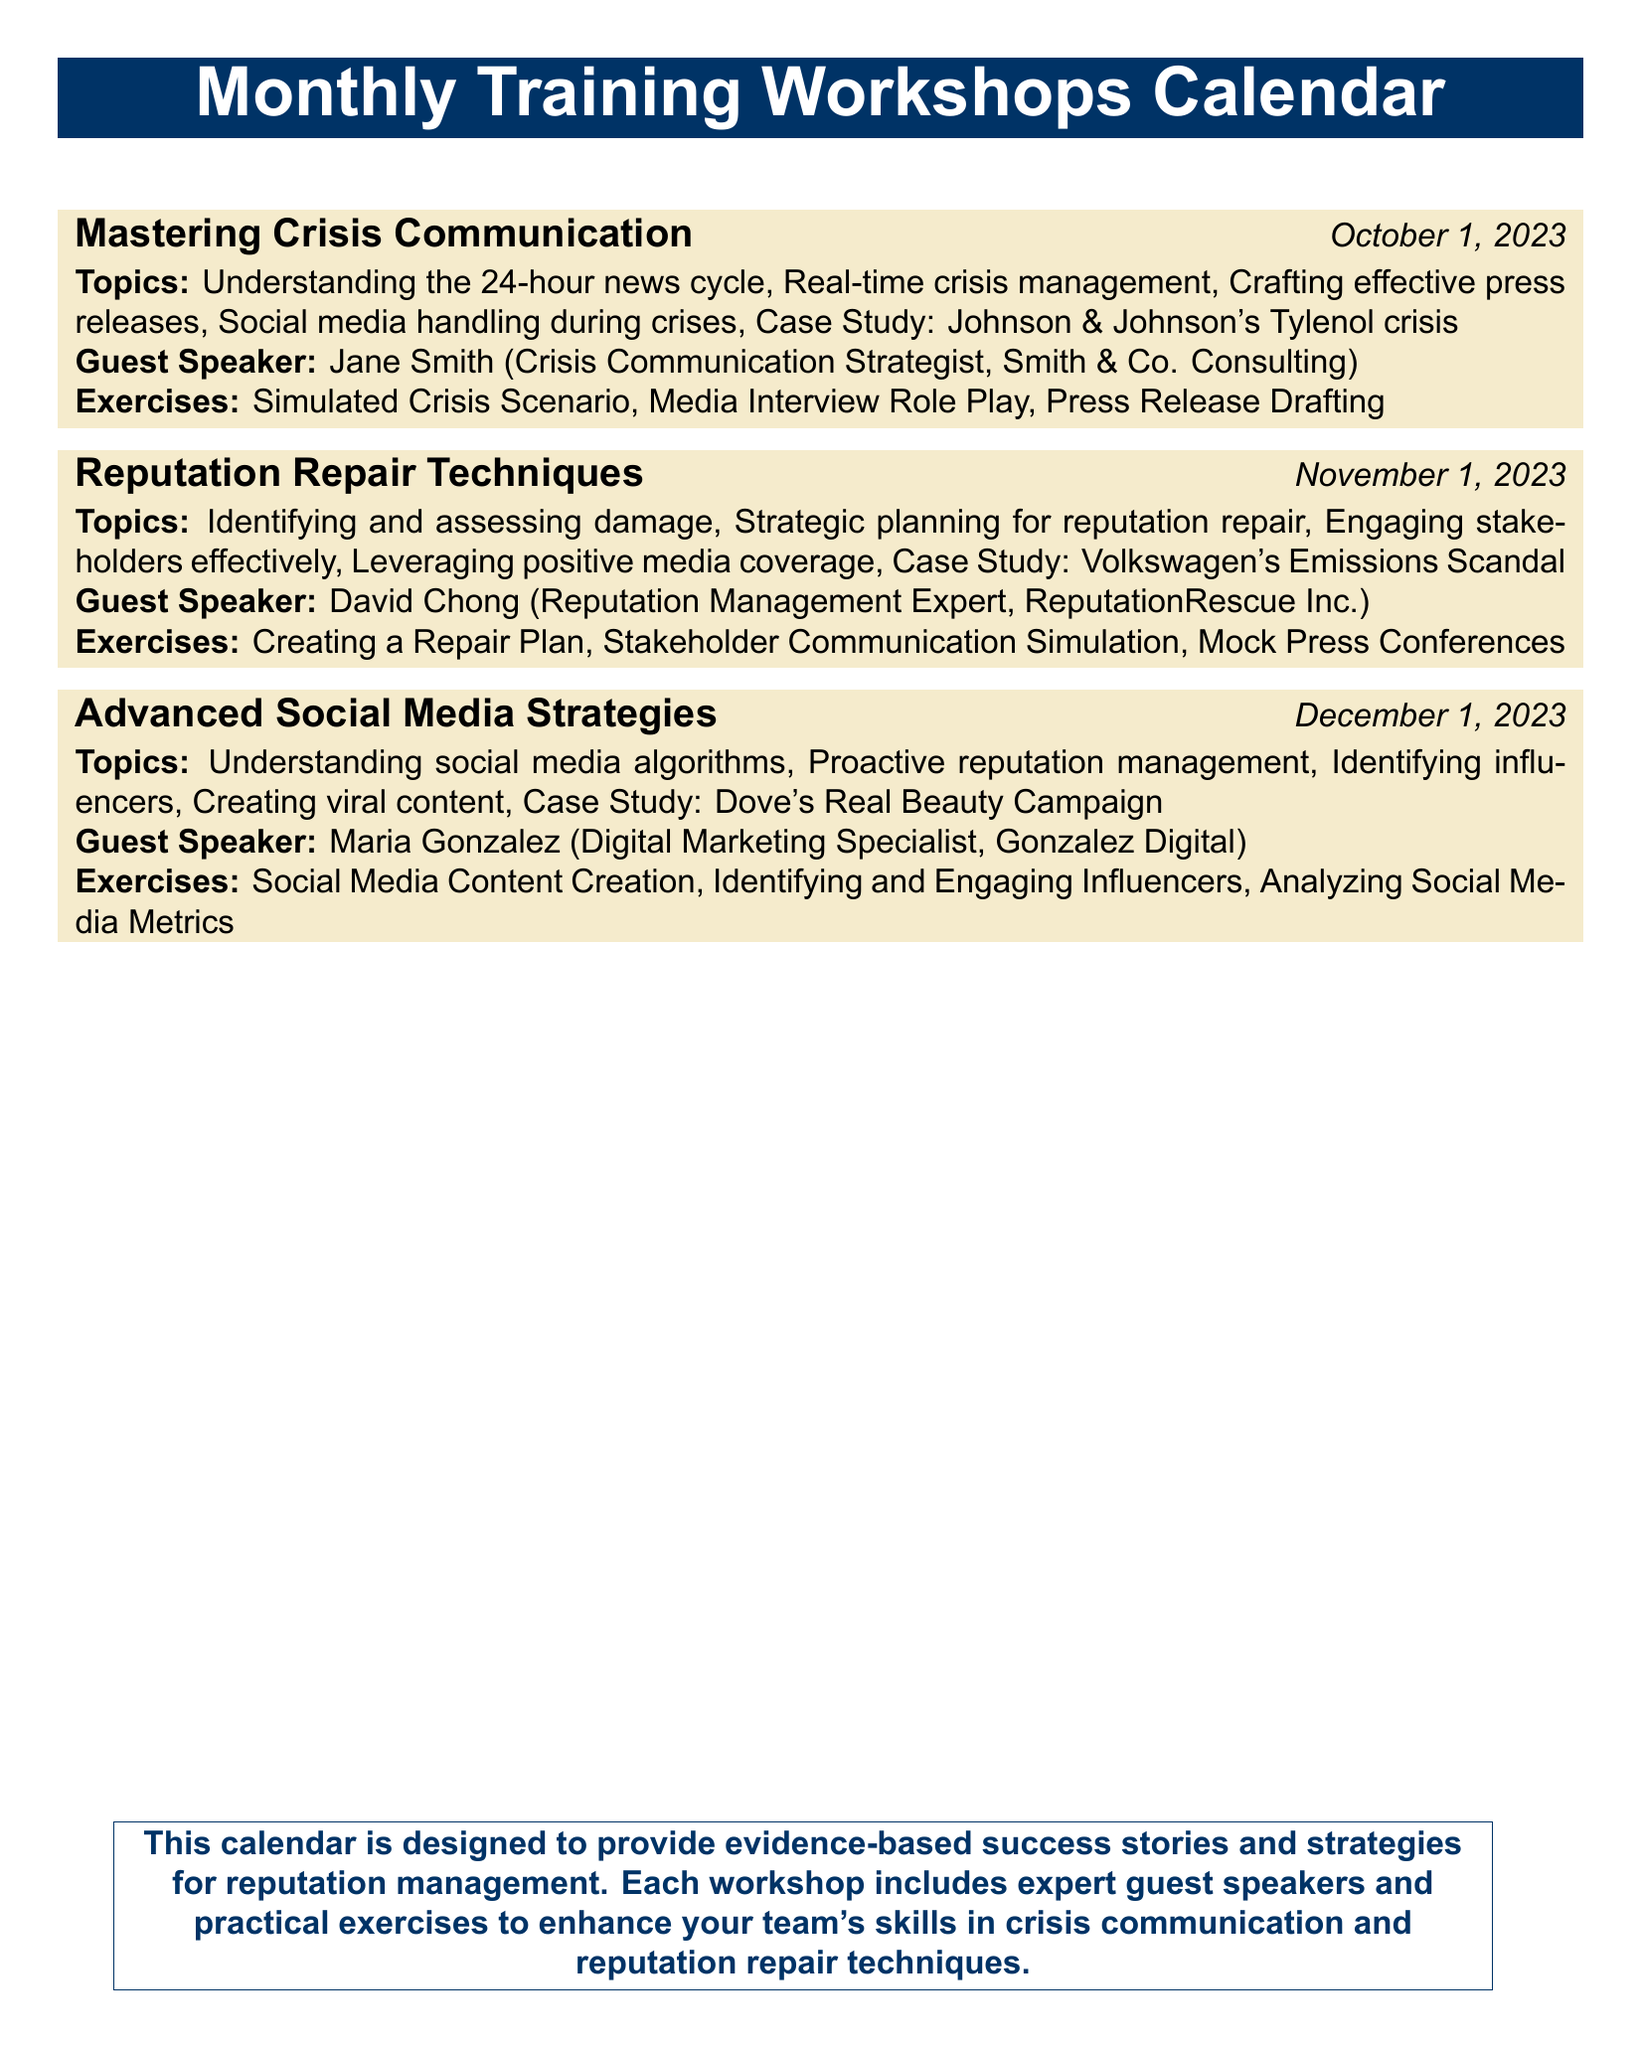What is the date of the workshop on crisis communication? The date for the "Mastering Crisis Communication" workshop is specifically mentioned in the document as October 1, 2023.
Answer: October 1, 2023 Who is the guest speaker for the November workshop? The document lists David Chong as the guest speaker for the "Reputation Repair Techniques" workshop scheduled for November.
Answer: David Chong What case study is covered in the workshop on reputation repair? The document mentions Volkswagen's Emissions Scandal as the case study associated with the "Reputation Repair Techniques" workshop.
Answer: Volkswagen's Emissions Scandal What type of exercise is included in the December workshop? The document states that the "Advanced Social Media Strategies" workshop includes an exercise on "Analyzing Social Media Metrics."
Answer: Analyzing Social Media Metrics How many workshops are scheduled in total? The document lists a total of three workshops taking place in different months.
Answer: Three What is the main focus of the December workshop? The document indicates that the December workshop focuses on advanced strategies related to social media.
Answer: Advanced Social Media Strategies Who is the speaker for the crisis communication workshop? The document identifies Jane Smith as the speaker for the "Mastering Crisis Communication" workshop.
Answer: Jane Smith What is a key topic covered in the crisis communication workshop? The document lists "Crafting effective press releases" as one of the key topics in the "Mastering Crisis Communication" workshop.
Answer: Crafting effective press releases 